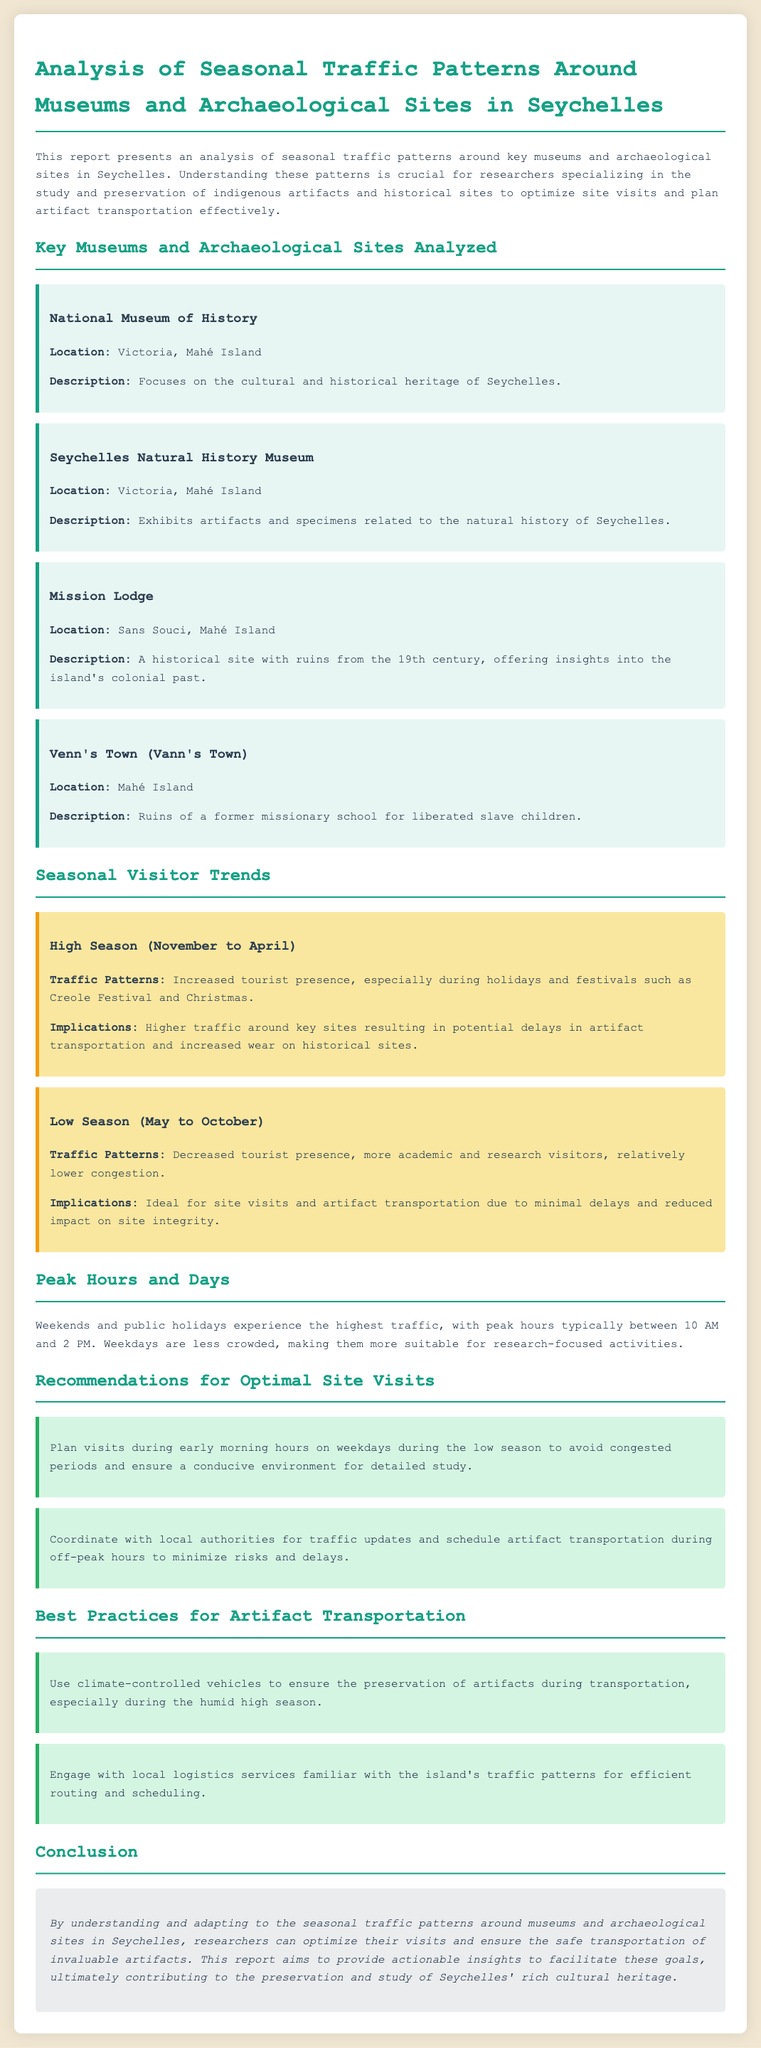What is the title of the report? The title is stated in the header of the document, which is "Analysis of Seasonal Traffic Patterns Around Museums and Archaeological Sites in Seychelles."
Answer: Analysis of Seasonal Traffic Patterns Around Museums and Archaeological Sites in Seychelles Where is the National Museum of History located? The location is provided in the site card for the National Museum of History, which states it is in Victoria, Mahé Island.
Answer: Victoria, Mahé Island What is the description of Mission Lodge? The description is found in the site card for Mission Lodge, detailing that it includes ruins from the 19th century, offering insights into the island's colonial past.
Answer: A historical site with ruins from the 19th century, offering insights into the island's colonial past During which months is the high season? The text indicates that the high season spans from November to April.
Answer: November to April What is the implication of high season traffic patterns? The implications of high season traffic, as stated in the document, include potential delays in artifact transportation and increased wear on historical sites.
Answer: Potential delays in artifact transportation and increased wear on historical sites What recommendation is made for optimal site visits? The recommendation for optimal site visits is provided in a specific recommendation card urging to plan visits during early morning hours on weekdays during the low season.
Answer: Plan visits during early morning hours on weekdays during the low season What is suggested for artifact transportation during the humid high season? The recommendation states to use climate-controlled vehicles for preservation during transportation in the humid high season.
Answer: Use climate-controlled vehicles Which days have the highest traffic according to the report? The report specifies that weekends and public holidays experience the highest traffic.
Answer: Weekends and public holidays What is a best practice for engaging with local logistics services? The document recommends engaging with local logistics services that are familiar with the island's traffic patterns for efficiency.
Answer: Familiar with the island's traffic patterns 